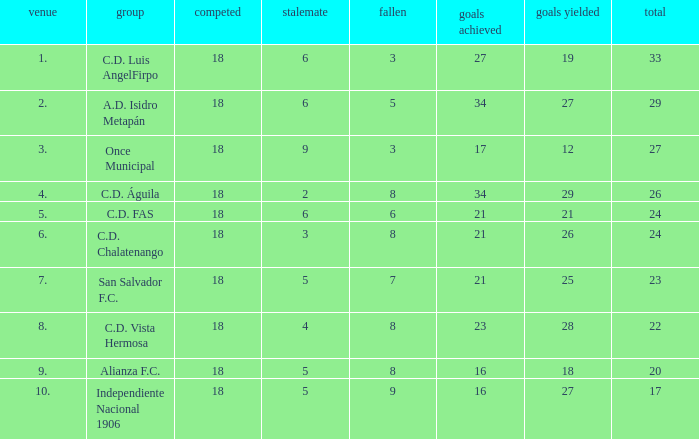How many points were in a game that had a lost of 5, greater than place 2, and 27 goals conceded? 0.0. 